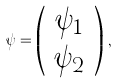<formula> <loc_0><loc_0><loc_500><loc_500>\psi = \left ( \begin{array} { c } \psi _ { 1 } \\ \psi _ { 2 } \end{array} \right ) \, ,</formula> 